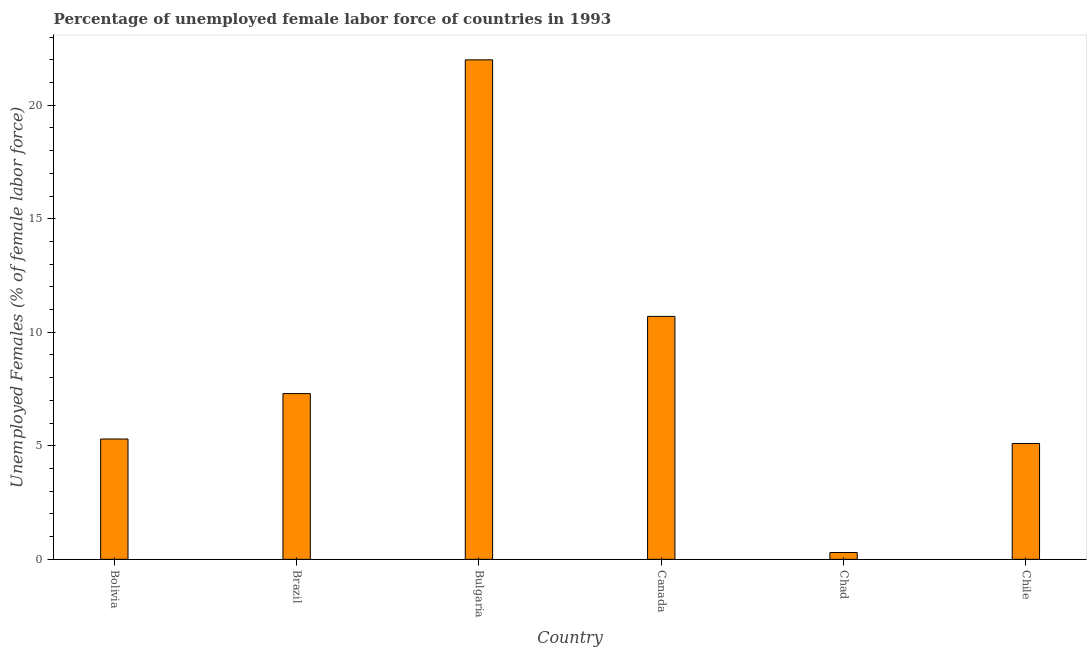Does the graph contain grids?
Offer a terse response. No. What is the title of the graph?
Your response must be concise. Percentage of unemployed female labor force of countries in 1993. What is the label or title of the X-axis?
Give a very brief answer. Country. What is the label or title of the Y-axis?
Make the answer very short. Unemployed Females (% of female labor force). What is the total unemployed female labour force in Brazil?
Give a very brief answer. 7.3. Across all countries, what is the maximum total unemployed female labour force?
Give a very brief answer. 22. Across all countries, what is the minimum total unemployed female labour force?
Provide a succinct answer. 0.3. In which country was the total unemployed female labour force minimum?
Offer a terse response. Chad. What is the sum of the total unemployed female labour force?
Make the answer very short. 50.7. What is the average total unemployed female labour force per country?
Your answer should be very brief. 8.45. What is the median total unemployed female labour force?
Make the answer very short. 6.3. In how many countries, is the total unemployed female labour force greater than 20 %?
Your response must be concise. 1. What is the ratio of the total unemployed female labour force in Canada to that in Chad?
Your answer should be compact. 35.67. What is the difference between the highest and the lowest total unemployed female labour force?
Offer a very short reply. 21.7. In how many countries, is the total unemployed female labour force greater than the average total unemployed female labour force taken over all countries?
Your answer should be very brief. 2. How many bars are there?
Provide a succinct answer. 6. Are all the bars in the graph horizontal?
Your response must be concise. No. How many countries are there in the graph?
Provide a succinct answer. 6. What is the difference between two consecutive major ticks on the Y-axis?
Offer a terse response. 5. Are the values on the major ticks of Y-axis written in scientific E-notation?
Provide a succinct answer. No. What is the Unemployed Females (% of female labor force) of Bolivia?
Make the answer very short. 5.3. What is the Unemployed Females (% of female labor force) in Brazil?
Your answer should be very brief. 7.3. What is the Unemployed Females (% of female labor force) of Bulgaria?
Offer a terse response. 22. What is the Unemployed Females (% of female labor force) in Canada?
Make the answer very short. 10.7. What is the Unemployed Females (% of female labor force) of Chad?
Give a very brief answer. 0.3. What is the Unemployed Females (% of female labor force) in Chile?
Your response must be concise. 5.1. What is the difference between the Unemployed Females (% of female labor force) in Bolivia and Bulgaria?
Your response must be concise. -16.7. What is the difference between the Unemployed Females (% of female labor force) in Brazil and Bulgaria?
Provide a succinct answer. -14.7. What is the difference between the Unemployed Females (% of female labor force) in Brazil and Chile?
Ensure brevity in your answer.  2.2. What is the difference between the Unemployed Females (% of female labor force) in Bulgaria and Chad?
Give a very brief answer. 21.7. What is the difference between the Unemployed Females (% of female labor force) in Canada and Chad?
Keep it short and to the point. 10.4. What is the difference between the Unemployed Females (% of female labor force) in Chad and Chile?
Make the answer very short. -4.8. What is the ratio of the Unemployed Females (% of female labor force) in Bolivia to that in Brazil?
Provide a short and direct response. 0.73. What is the ratio of the Unemployed Females (% of female labor force) in Bolivia to that in Bulgaria?
Offer a very short reply. 0.24. What is the ratio of the Unemployed Females (% of female labor force) in Bolivia to that in Canada?
Ensure brevity in your answer.  0.49. What is the ratio of the Unemployed Females (% of female labor force) in Bolivia to that in Chad?
Keep it short and to the point. 17.67. What is the ratio of the Unemployed Females (% of female labor force) in Bolivia to that in Chile?
Offer a very short reply. 1.04. What is the ratio of the Unemployed Females (% of female labor force) in Brazil to that in Bulgaria?
Offer a very short reply. 0.33. What is the ratio of the Unemployed Females (% of female labor force) in Brazil to that in Canada?
Ensure brevity in your answer.  0.68. What is the ratio of the Unemployed Females (% of female labor force) in Brazil to that in Chad?
Ensure brevity in your answer.  24.33. What is the ratio of the Unemployed Females (% of female labor force) in Brazil to that in Chile?
Your answer should be compact. 1.43. What is the ratio of the Unemployed Females (% of female labor force) in Bulgaria to that in Canada?
Provide a short and direct response. 2.06. What is the ratio of the Unemployed Females (% of female labor force) in Bulgaria to that in Chad?
Your answer should be very brief. 73.33. What is the ratio of the Unemployed Females (% of female labor force) in Bulgaria to that in Chile?
Ensure brevity in your answer.  4.31. What is the ratio of the Unemployed Females (% of female labor force) in Canada to that in Chad?
Your response must be concise. 35.67. What is the ratio of the Unemployed Females (% of female labor force) in Canada to that in Chile?
Your response must be concise. 2.1. What is the ratio of the Unemployed Females (% of female labor force) in Chad to that in Chile?
Offer a very short reply. 0.06. 